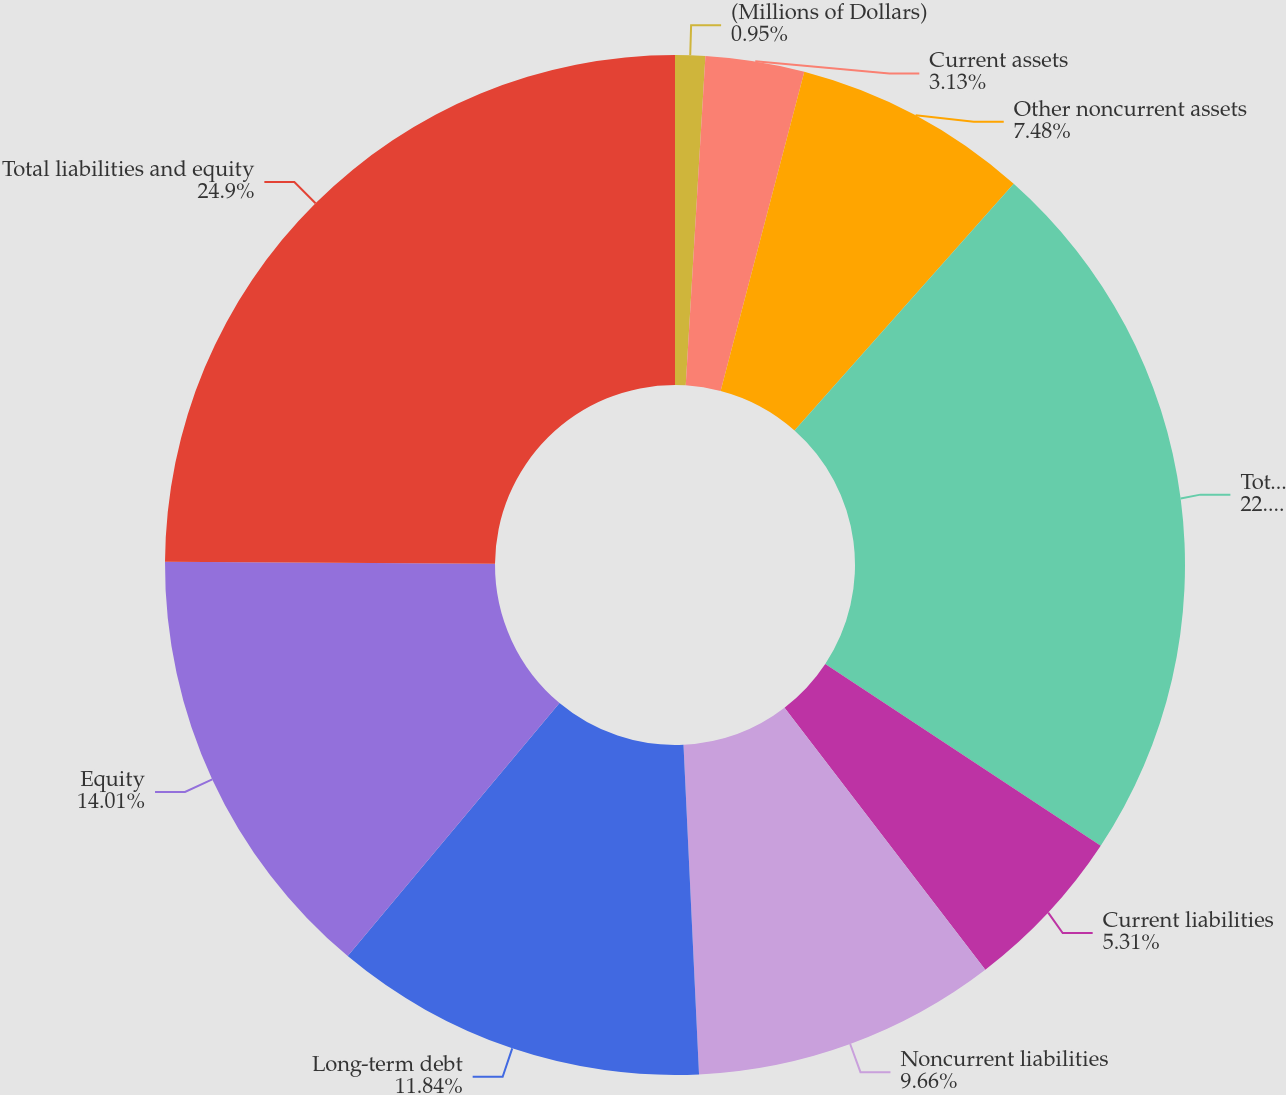Convert chart. <chart><loc_0><loc_0><loc_500><loc_500><pie_chart><fcel>(Millions of Dollars)<fcel>Current assets<fcel>Other noncurrent assets<fcel>Total Assets<fcel>Current liabilities<fcel>Noncurrent liabilities<fcel>Long-term debt<fcel>Equity<fcel>Total liabilities and equity<nl><fcel>0.95%<fcel>3.13%<fcel>7.48%<fcel>22.72%<fcel>5.31%<fcel>9.66%<fcel>11.84%<fcel>14.01%<fcel>24.9%<nl></chart> 